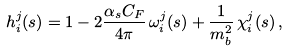Convert formula to latex. <formula><loc_0><loc_0><loc_500><loc_500>h _ { i } ^ { j } ( s ) = 1 - 2 \frac { \alpha _ { s } C _ { F } } { 4 \pi } \, \omega _ { i } ^ { j } ( s ) + \frac { 1 } { m _ { b } ^ { 2 } } \, \chi ^ { j } _ { i } ( s ) \, ,</formula> 